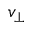<formula> <loc_0><loc_0><loc_500><loc_500>v _ { \perp }</formula> 